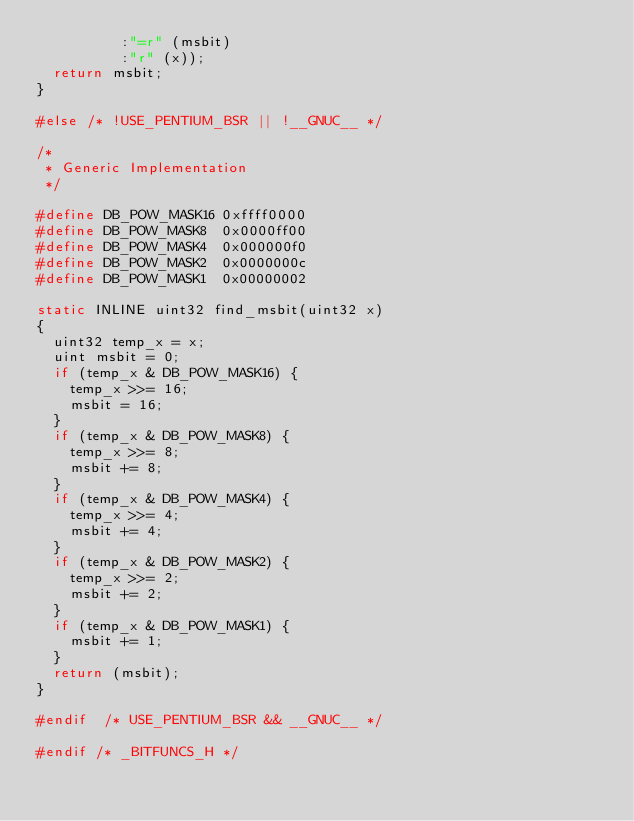Convert code to text. <code><loc_0><loc_0><loc_500><loc_500><_C_>	        :"=r" (msbit)
	        :"r" (x));
	return msbit;
}

#else	/* !USE_PENTIUM_BSR || !__GNUC__ */

/*
 * Generic Implementation
 */

#define DB_POW_MASK16	0xffff0000
#define DB_POW_MASK8	0x0000ff00
#define DB_POW_MASK4	0x000000f0
#define DB_POW_MASK2	0x0000000c
#define DB_POW_MASK1	0x00000002

static INLINE uint32 find_msbit(uint32 x)
{
	uint32 temp_x = x;
	uint msbit = 0;
	if (temp_x & DB_POW_MASK16) {
		temp_x >>= 16;
		msbit = 16;
	}
	if (temp_x & DB_POW_MASK8) {
		temp_x >>= 8;
		msbit += 8;
	}
	if (temp_x & DB_POW_MASK4) {
		temp_x >>= 4;
		msbit += 4;
	}
	if (temp_x & DB_POW_MASK2) {
		temp_x >>= 2;
		msbit += 2;
	}
	if (temp_x & DB_POW_MASK1) {
		msbit += 1;
	}
	return (msbit);
}

#endif	/* USE_PENTIUM_BSR && __GNUC__ */

#endif /* _BITFUNCS_H */
</code> 